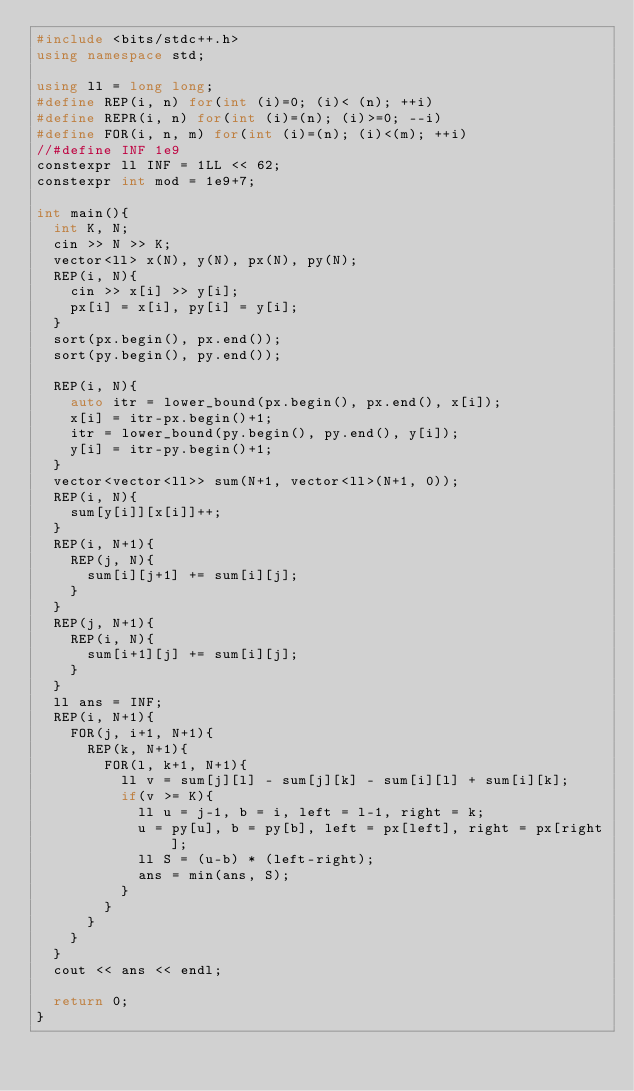Convert code to text. <code><loc_0><loc_0><loc_500><loc_500><_C++_>#include <bits/stdc++.h>
using namespace std;

using ll = long long;
#define REP(i, n) for(int (i)=0; (i)< (n); ++i)
#define REPR(i, n) for(int (i)=(n); (i)>=0; --i)
#define FOR(i, n, m) for(int (i)=(n); (i)<(m); ++i)
//#define INF 1e9
constexpr ll INF = 1LL << 62;
constexpr int mod = 1e9+7;

int main(){
  int K, N;
  cin >> N >> K;
  vector<ll> x(N), y(N), px(N), py(N);
  REP(i, N){
    cin >> x[i] >> y[i];
    px[i] = x[i], py[i] = y[i];
  }
  sort(px.begin(), px.end());
  sort(py.begin(), py.end());
  
  REP(i, N){
    auto itr = lower_bound(px.begin(), px.end(), x[i]);
    x[i] = itr-px.begin()+1;
    itr = lower_bound(py.begin(), py.end(), y[i]);
    y[i] = itr-py.begin()+1;
  }
  vector<vector<ll>> sum(N+1, vector<ll>(N+1, 0));
  REP(i, N){
    sum[y[i]][x[i]]++;
  }
  REP(i, N+1){
    REP(j, N){
      sum[i][j+1] += sum[i][j];
    }
  }
  REP(j, N+1){
    REP(i, N){
      sum[i+1][j] += sum[i][j];
    }
  }
  ll ans = INF;
  REP(i, N+1){
    FOR(j, i+1, N+1){
      REP(k, N+1){
        FOR(l, k+1, N+1){
          ll v = sum[j][l] - sum[j][k] - sum[i][l] + sum[i][k];
          if(v >= K){
            ll u = j-1, b = i, left = l-1, right = k;
            u = py[u], b = py[b], left = px[left], right = px[right];
            ll S = (u-b) * (left-right);
            ans = min(ans, S);
          }
        }
      }
    }
  }
  cout << ans << endl;

  return 0;
}
</code> 